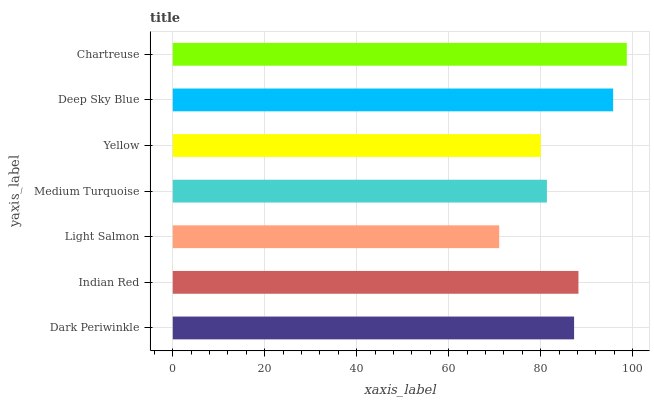Is Light Salmon the minimum?
Answer yes or no. Yes. Is Chartreuse the maximum?
Answer yes or no. Yes. Is Indian Red the minimum?
Answer yes or no. No. Is Indian Red the maximum?
Answer yes or no. No. Is Indian Red greater than Dark Periwinkle?
Answer yes or no. Yes. Is Dark Periwinkle less than Indian Red?
Answer yes or no. Yes. Is Dark Periwinkle greater than Indian Red?
Answer yes or no. No. Is Indian Red less than Dark Periwinkle?
Answer yes or no. No. Is Dark Periwinkle the high median?
Answer yes or no. Yes. Is Dark Periwinkle the low median?
Answer yes or no. Yes. Is Indian Red the high median?
Answer yes or no. No. Is Deep Sky Blue the low median?
Answer yes or no. No. 